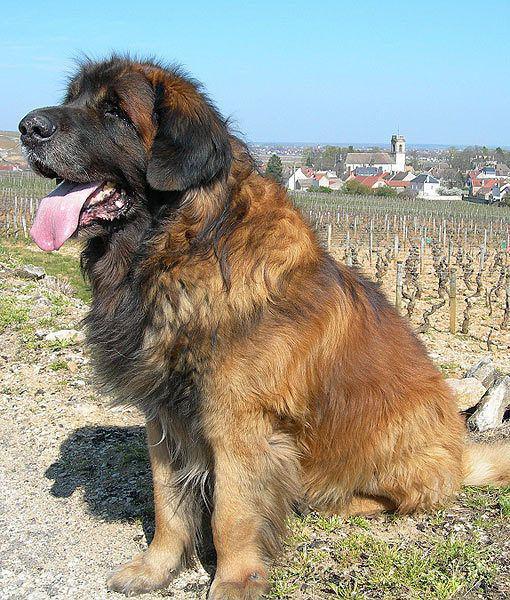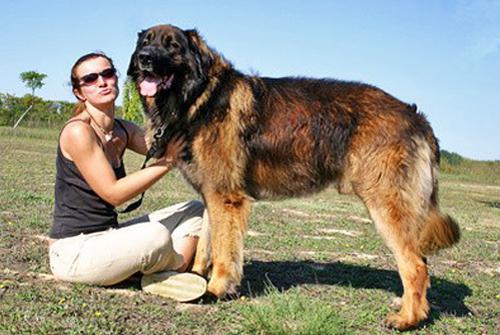The first image is the image on the left, the second image is the image on the right. Analyze the images presented: Is the assertion "At least one image shows two mammals." valid? Answer yes or no. Yes. The first image is the image on the left, the second image is the image on the right. Examine the images to the left and right. Is the description "In one image, two dogs of the same breed are near a fence, while the other image shows a single dog with its mouth open and tongue visible." accurate? Answer yes or no. No. The first image is the image on the left, the second image is the image on the right. Assess this claim about the two images: "Two dogs in similar poses are facing some type of fence in one image.". Correct or not? Answer yes or no. No. The first image is the image on the left, the second image is the image on the right. For the images displayed, is the sentence "There is one dog sitting in one image." factually correct? Answer yes or no. Yes. 